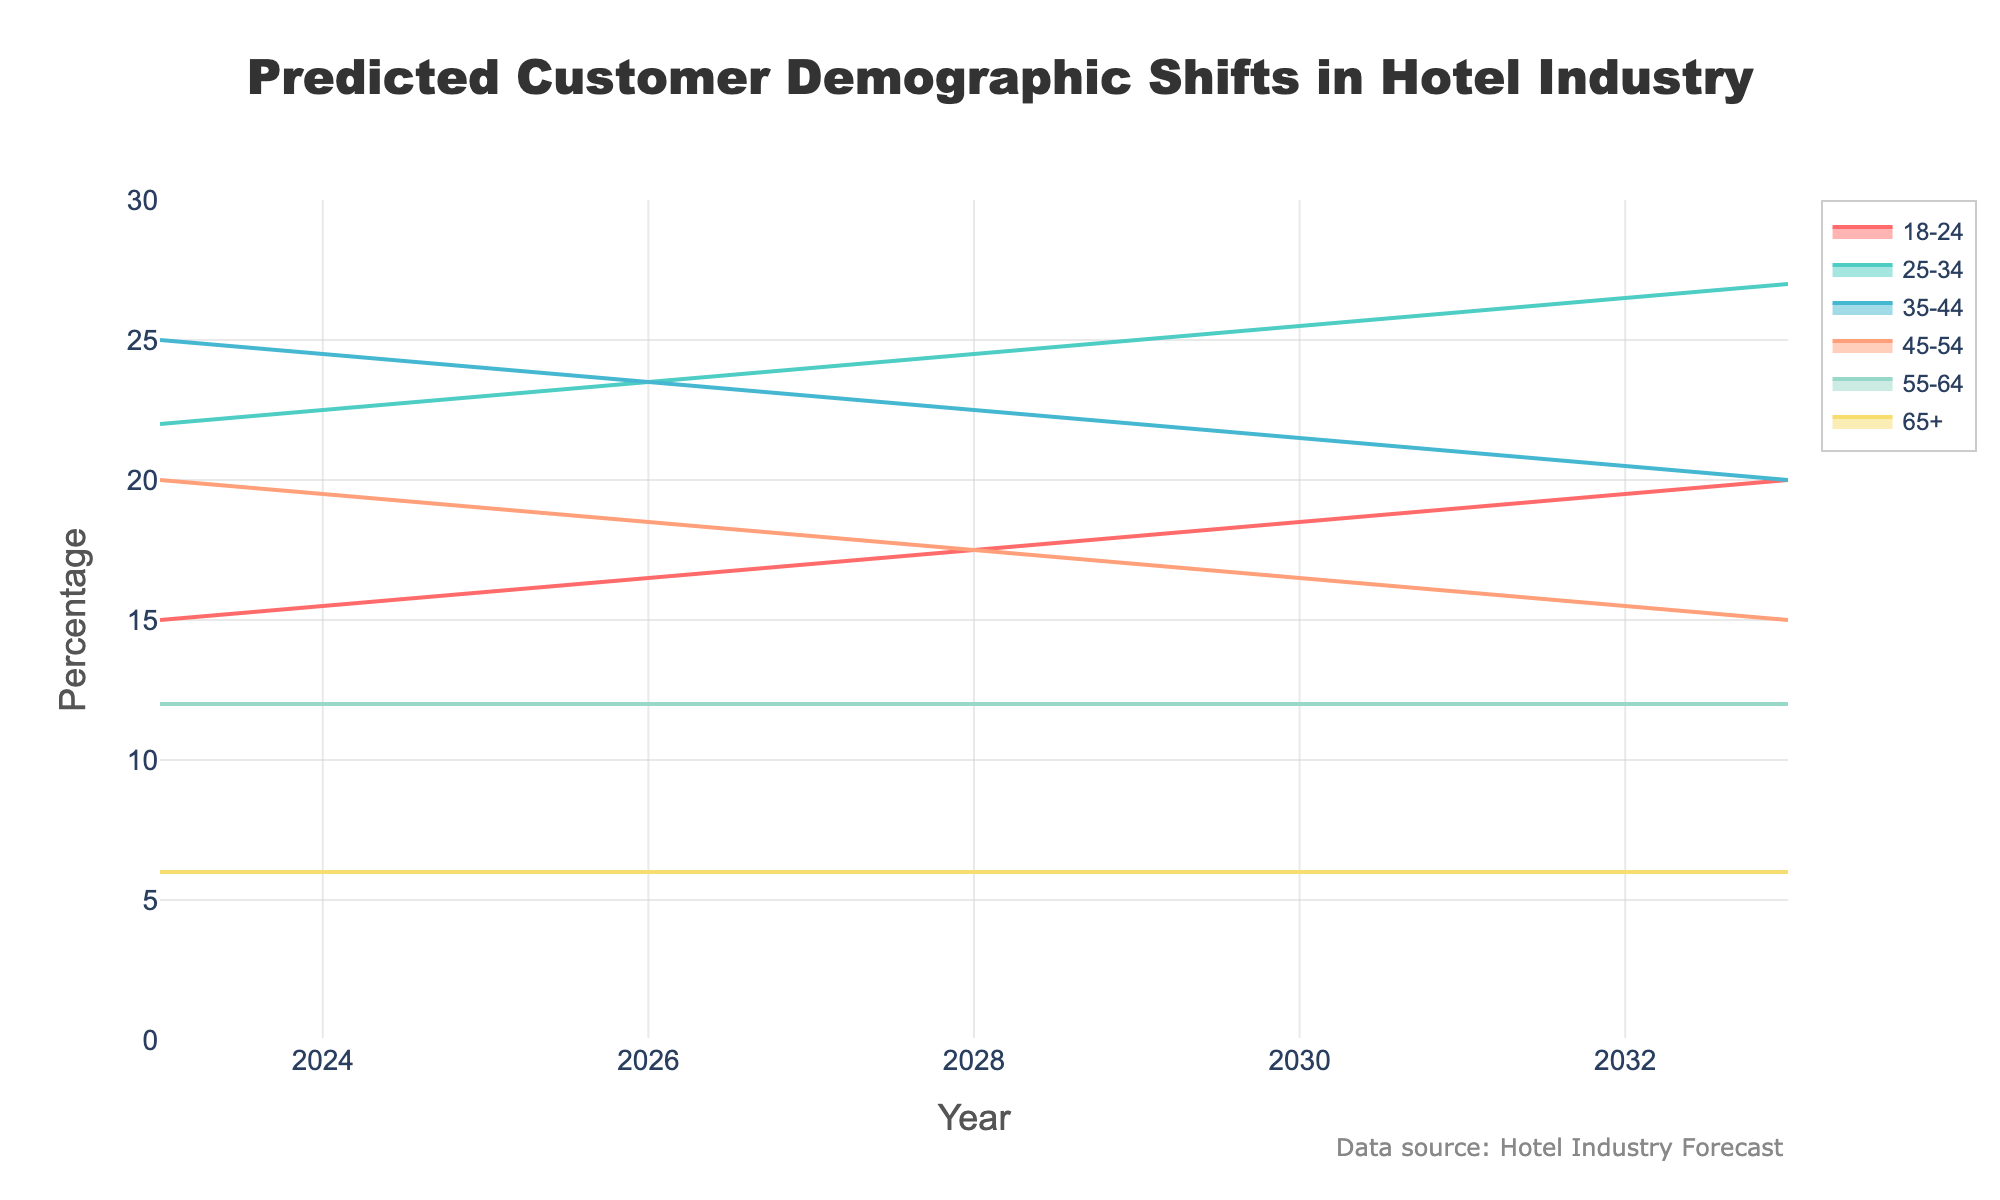What is the title of the figure? The title of the figure is clearly displayed at the top and it reads, "Predicted Customer Demographic Shifts in Hotel Industry".
Answer: Predicted Customer Demographic Shifts in Hotel Industry How does the percentage of customers aged 18-24 change from 2023 to 2033? The percentage of customers aged 18-24 starts at 15% in 2023 and increases to 20% in 2033.
Answer: Increases from 15% to 20% Which age group maintains a constant percentage over the years? By examining the lines representing each age group, the 55-64 and 65+ age groups both have a consistent percentage of 12% and 6%, respectively, throughout the years.
Answer: 55-64 and 65+ In what year do the 25-34 and 45-54 age groups have equal percentages, and what is that percentage? By analyzing the graph, the curves for the 25-34 and 45-54 age groups meet at different percentages over the years. However, they are equal at 19% in 2025.
Answer: 2025, 19% How does the percentage for the age group 35-44 change over the years? From the chart, the percentage for the 35-44 age group decreases from 25% in 2023 to 20% in 2033.
Answer: Decreases from 25% to 20% Which age group shows the most significant increase in percentage over the decade? By studying the trends, the age group 18-24 shows the most significant increase from 15% in 2023 to 20% in 2033, an increase of 5%.
Answer: 18-24 Compare the percentage change of the 18-24 age group and the 45-54 age group from 2023 to 2033. Which has a higher change and by how much? The 18-24 age group increases by 5% (from 15% to 20%), while the 45-54 age group decreases by 5% (from 20% to 15%). The absolute change for both groups is 5%, but in different directions.
Answer: Both have the same absolute change of 5% What is the overall trend in the percentage of customers aged 65+ from 2023 to 2033? The percentage for customers aged 65+ remains constant at 6% throughout the years 2023 to 2033.
Answer: Remains constant In which year does the percentage of customers aged 25-34 surpass the percentage of customers aged 35-44 for the first time? By examining the trend lines, the percentage of customers aged 25-34 first surpasses those aged 35-44 in 2027.
Answer: 2027 What is the combined percentage of customers aged 35-44 and 45-54 in 2025? The percentage of customers aged 35-44 in 2025 is 24% and for aged 45-54 is 19%. Adding these together gives 24% + 19% = 43%.
Answer: 43% 